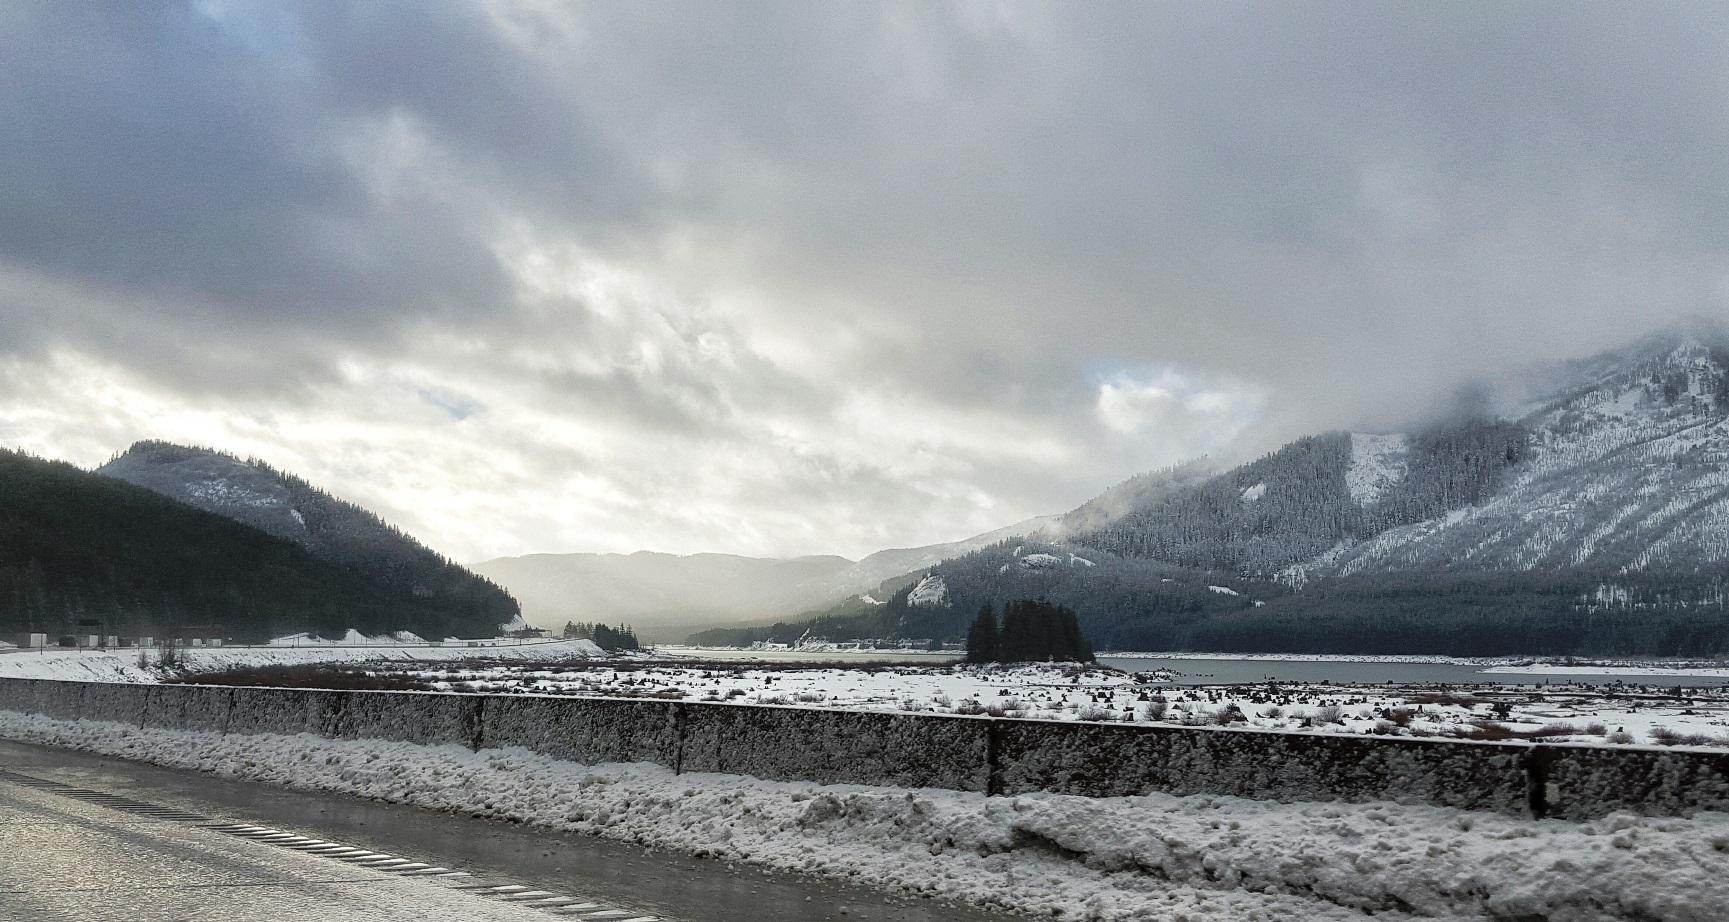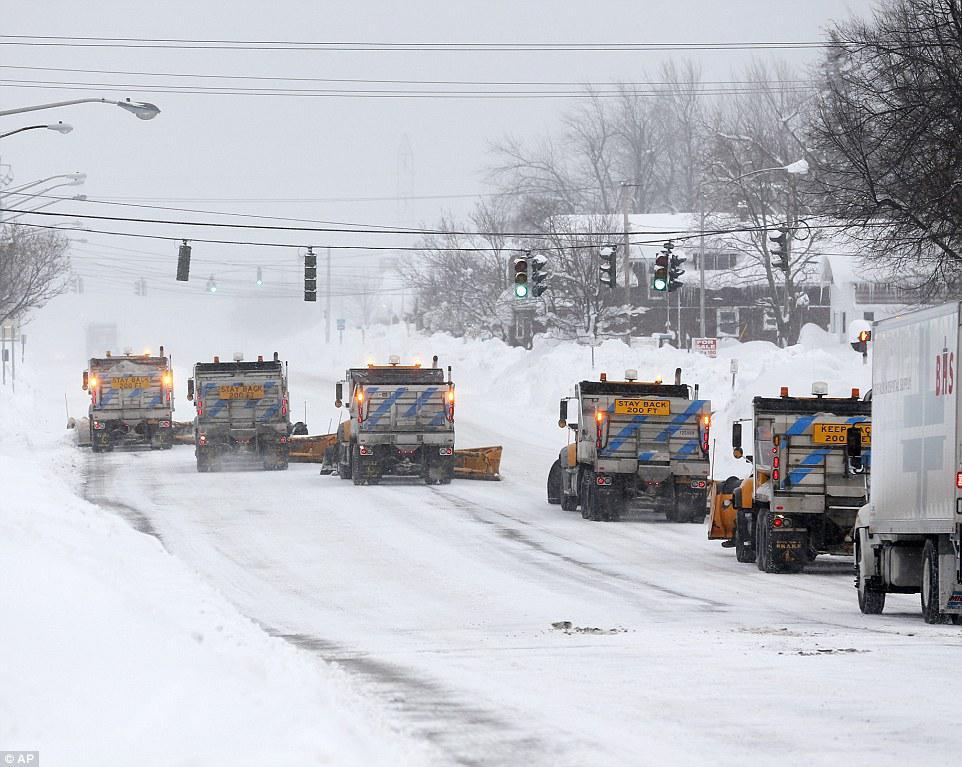The first image is the image on the left, the second image is the image on the right. Examine the images to the left and right. Is the description "More than one snowplow truck is present on a snowy road." accurate? Answer yes or no. Yes. The first image is the image on the left, the second image is the image on the right. Given the left and right images, does the statement "there are at least two vehicles in one of the images" hold true? Answer yes or no. Yes. 